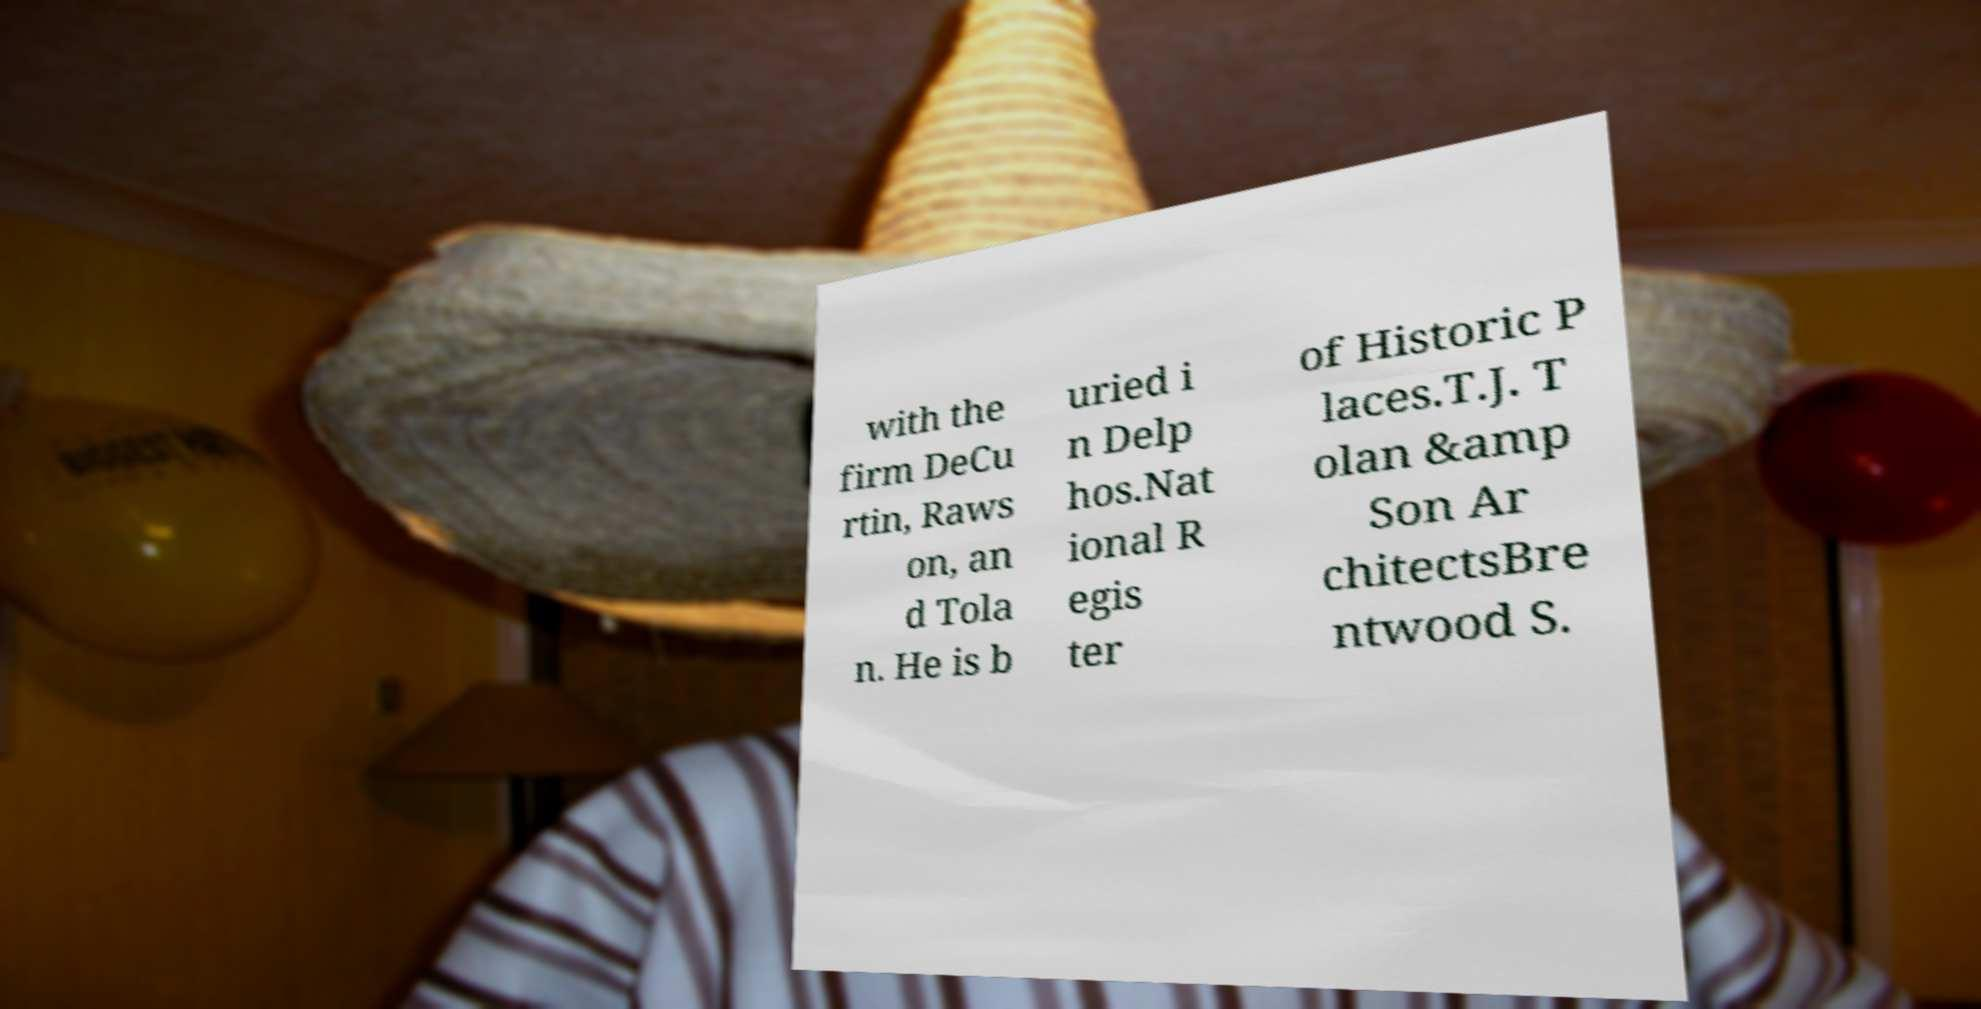Could you extract and type out the text from this image? with the firm DeCu rtin, Raws on, an d Tola n. He is b uried i n Delp hos.Nat ional R egis ter of Historic P laces.T.J. T olan &amp Son Ar chitectsBre ntwood S. 